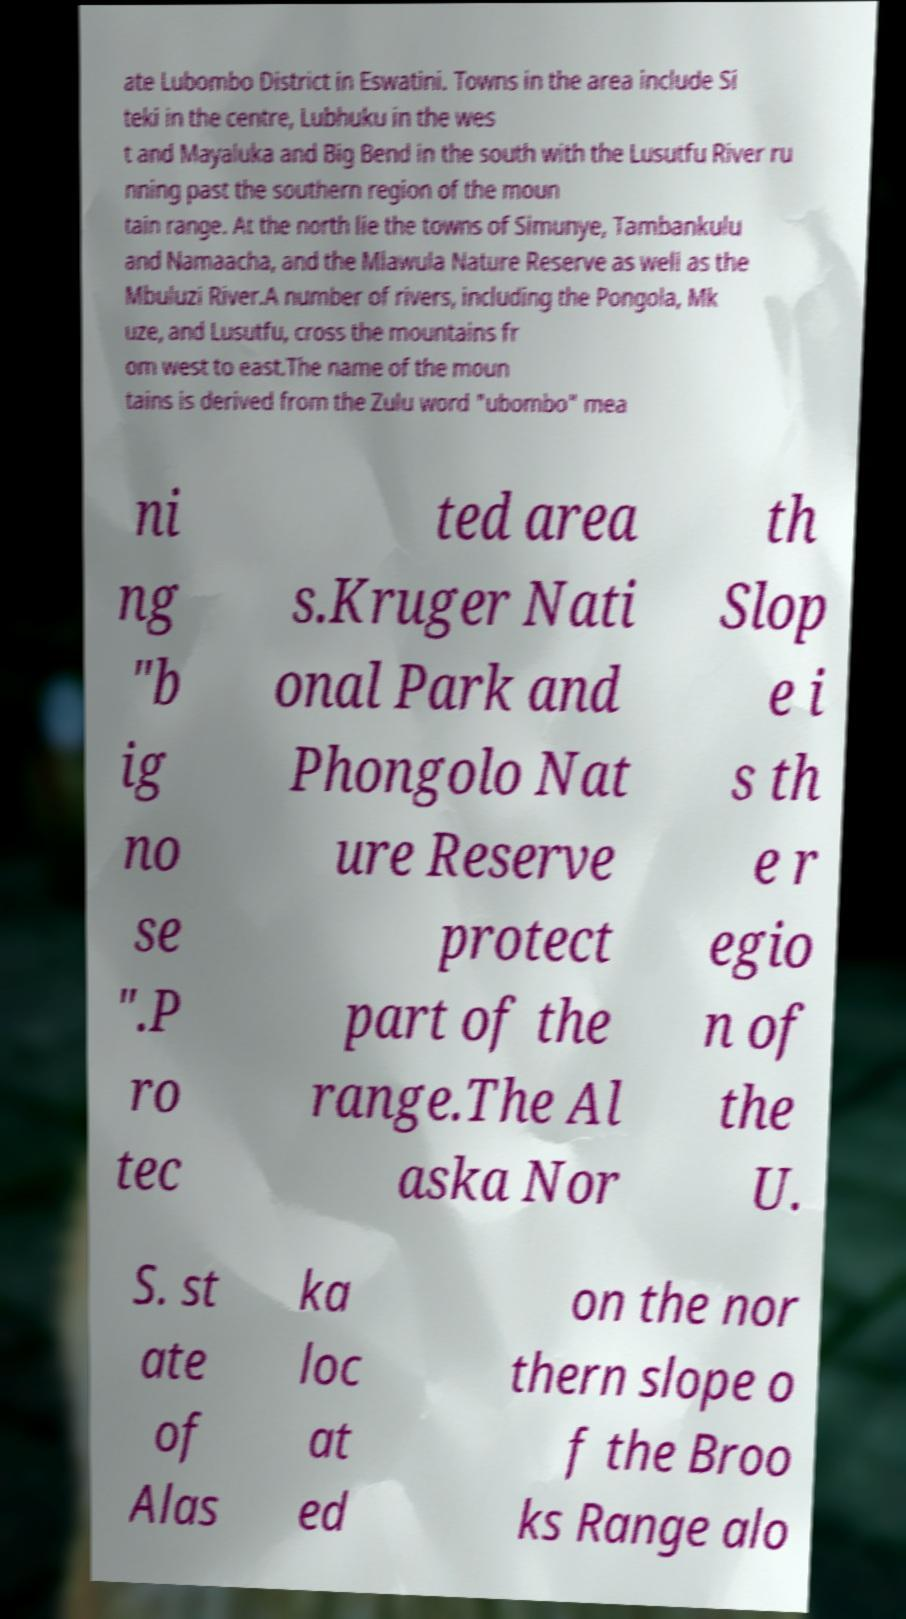Please read and relay the text visible in this image. What does it say? ate Lubombo District in Eswatini. Towns in the area include Si teki in the centre, Lubhuku in the wes t and Mayaluka and Big Bend in the south with the Lusutfu River ru nning past the southern region of the moun tain range. At the north lie the towns of Simunye, Tambankulu and Namaacha, and the Mlawula Nature Reserve as well as the Mbuluzi River.A number of rivers, including the Pongola, Mk uze, and Lusutfu, cross the mountains fr om west to east.The name of the moun tains is derived from the Zulu word "ubombo" mea ni ng "b ig no se ".P ro tec ted area s.Kruger Nati onal Park and Phongolo Nat ure Reserve protect part of the range.The Al aska Nor th Slop e i s th e r egio n of the U. S. st ate of Alas ka loc at ed on the nor thern slope o f the Broo ks Range alo 